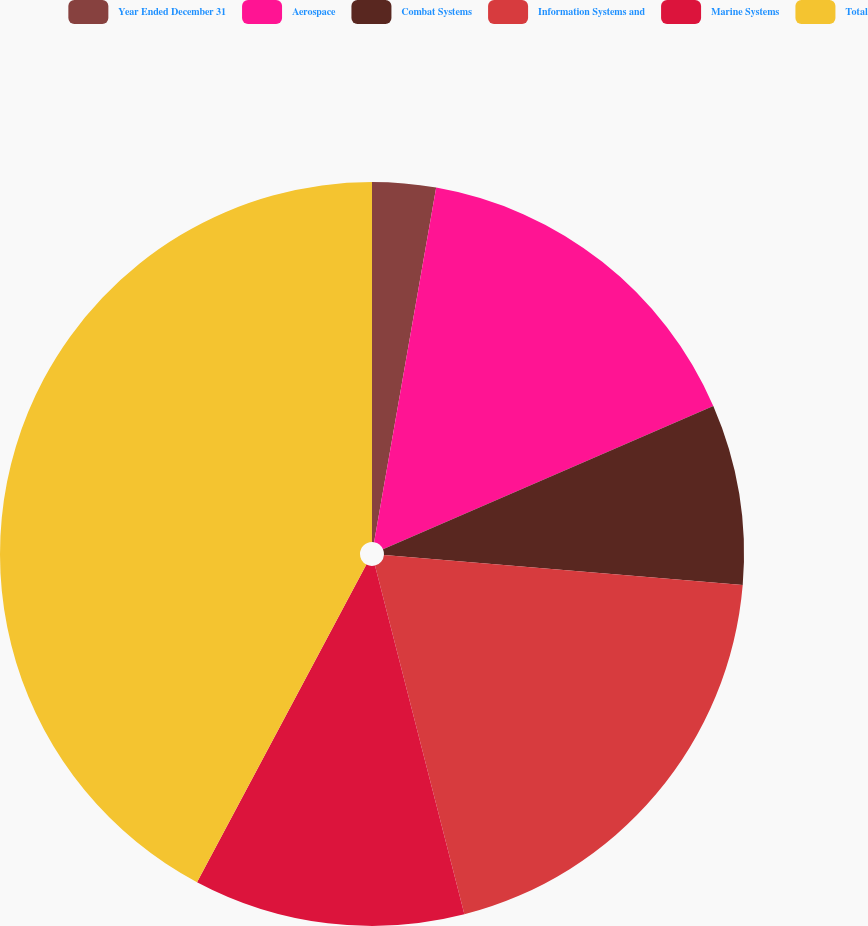Convert chart to OTSL. <chart><loc_0><loc_0><loc_500><loc_500><pie_chart><fcel>Year Ended December 31<fcel>Aerospace<fcel>Combat Systems<fcel>Information Systems and<fcel>Marine Systems<fcel>Total<nl><fcel>2.76%<fcel>15.73%<fcel>7.84%<fcel>19.68%<fcel>11.79%<fcel>42.21%<nl></chart> 